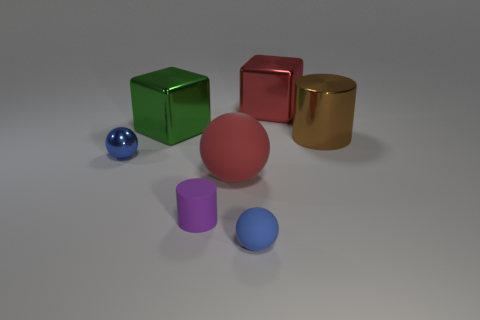Add 2 large spheres. How many objects exist? 9 Subtract all cylinders. How many objects are left? 5 Add 7 cylinders. How many cylinders exist? 9 Subtract 2 blue spheres. How many objects are left? 5 Subtract all yellow matte spheres. Subtract all small spheres. How many objects are left? 5 Add 5 big red cubes. How many big red cubes are left? 6 